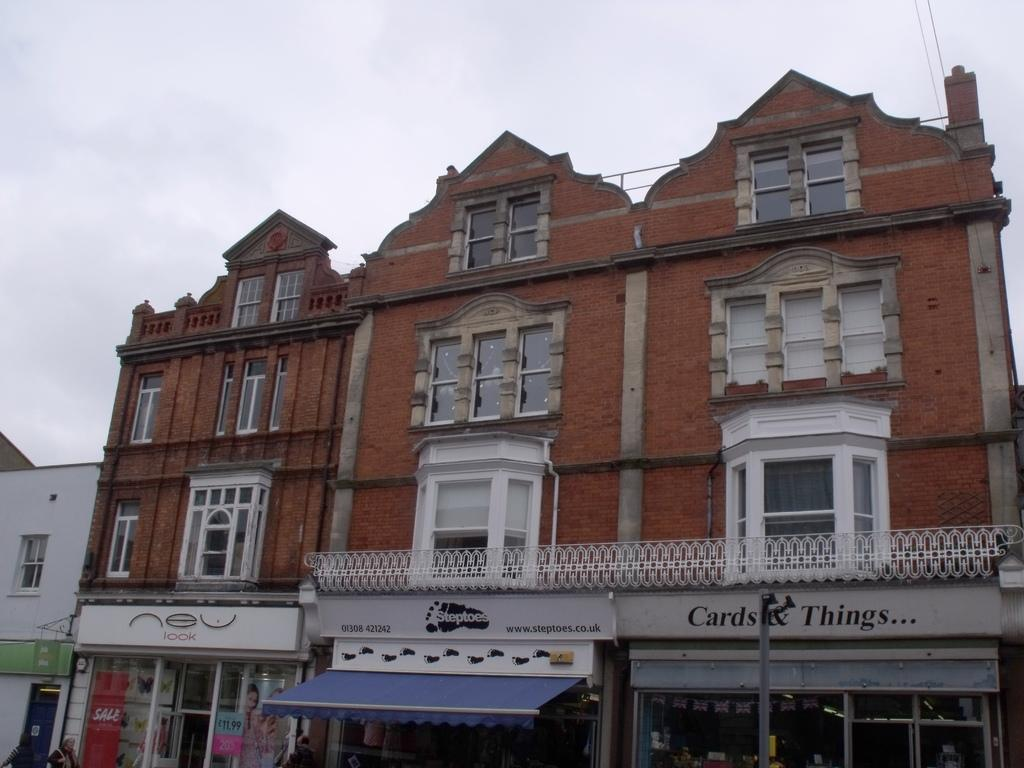What type of structures can be seen in the image? There are buildings in the image. What type of establishments are located at the bottom of the image? There are stores at the bottom of the image. Are there any people present in the image? Yes, people are visible in the image. What object can be seen standing upright in the image? There is a pole in the image. What can be seen in the background of the image? The sky is visible in the background of the image. What type of apparel is being displayed on the pole in the image? There is no apparel displayed on the pole in the image; it is just a plain pole. What kind of waste can be seen being disposed of in the image? There is no waste present in the image; it only shows buildings, stores, people, a pole, and the sky. 